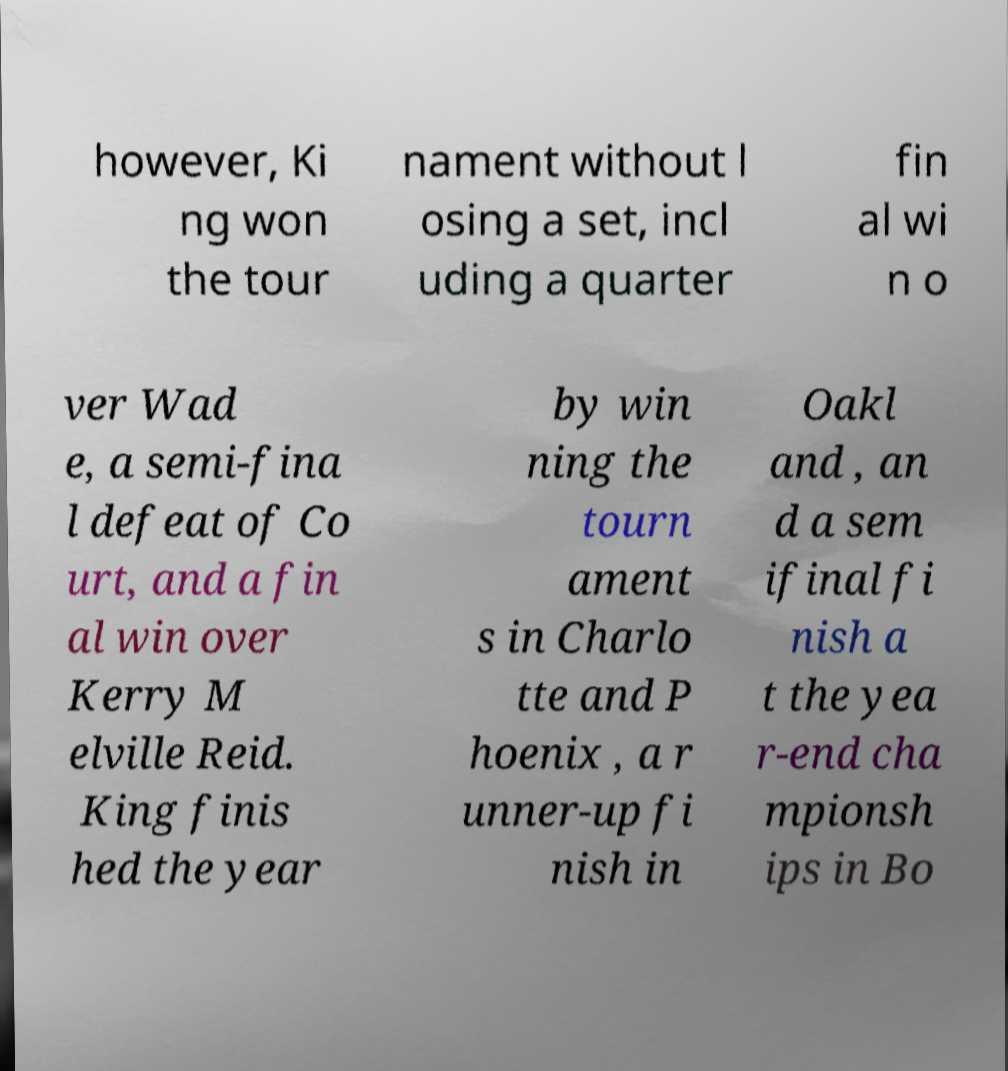Can you read and provide the text displayed in the image?This photo seems to have some interesting text. Can you extract and type it out for me? however, Ki ng won the tour nament without l osing a set, incl uding a quarter fin al wi n o ver Wad e, a semi-fina l defeat of Co urt, and a fin al win over Kerry M elville Reid. King finis hed the year by win ning the tourn ament s in Charlo tte and P hoenix , a r unner-up fi nish in Oakl and , an d a sem ifinal fi nish a t the yea r-end cha mpionsh ips in Bo 